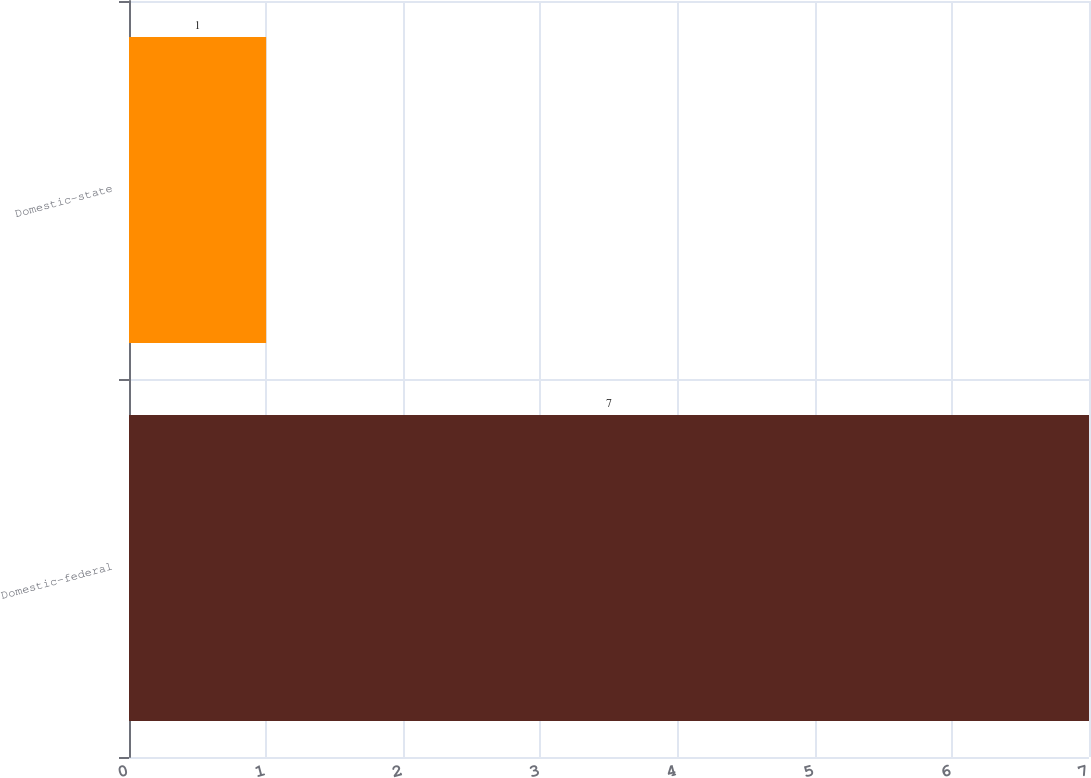Convert chart to OTSL. <chart><loc_0><loc_0><loc_500><loc_500><bar_chart><fcel>Domestic-federal<fcel>Domestic-state<nl><fcel>7<fcel>1<nl></chart> 